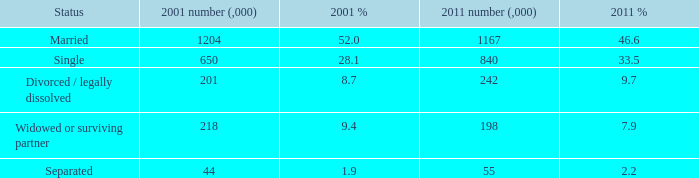What is the 2011 number (,000) when the status is separated? 55.0. 